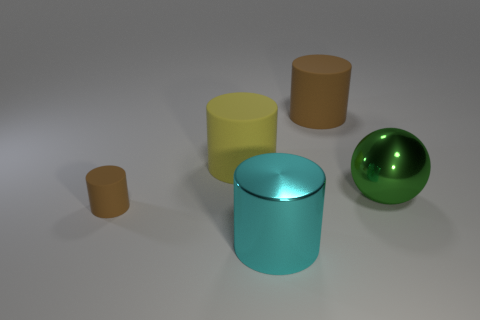Add 2 green metal spheres. How many objects exist? 7 Subtract all cylinders. How many objects are left? 1 Add 1 big things. How many big things are left? 5 Add 3 blue cylinders. How many blue cylinders exist? 3 Subtract 2 brown cylinders. How many objects are left? 3 Subtract all gray matte objects. Subtract all small brown rubber cylinders. How many objects are left? 4 